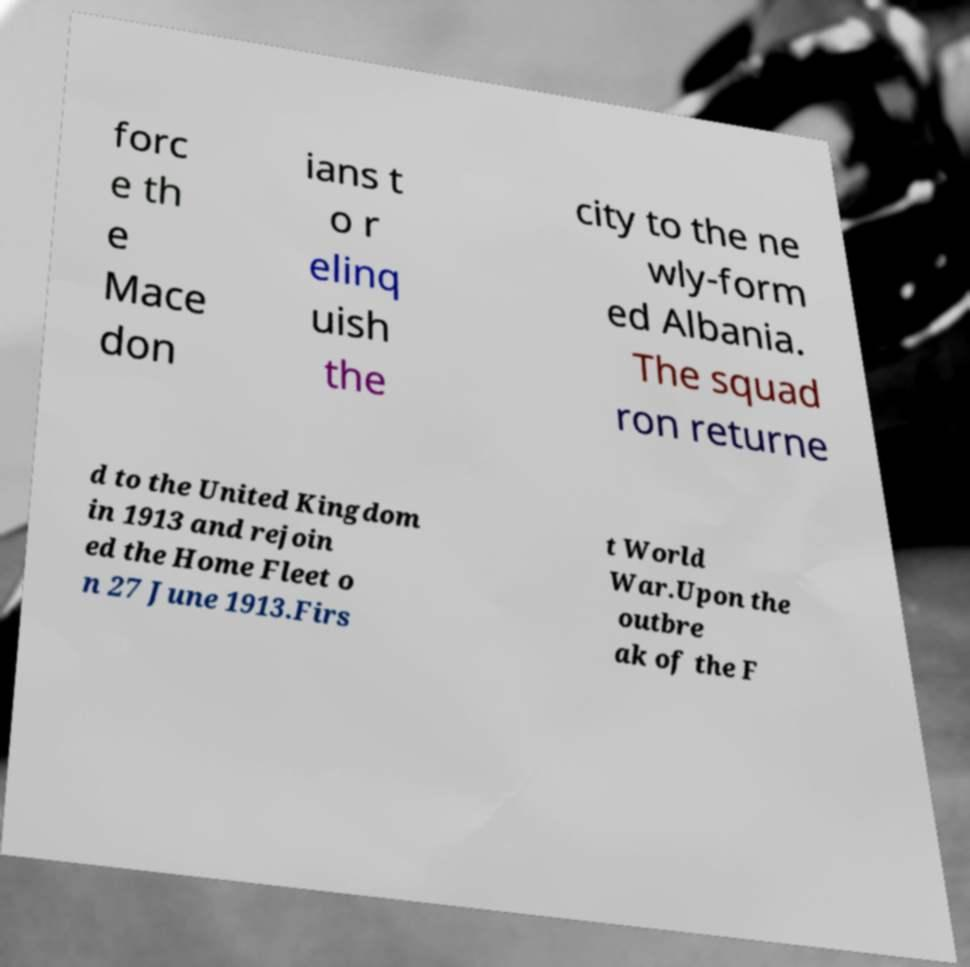For documentation purposes, I need the text within this image transcribed. Could you provide that? forc e th e Mace don ians t o r elinq uish the city to the ne wly-form ed Albania. The squad ron returne d to the United Kingdom in 1913 and rejoin ed the Home Fleet o n 27 June 1913.Firs t World War.Upon the outbre ak of the F 